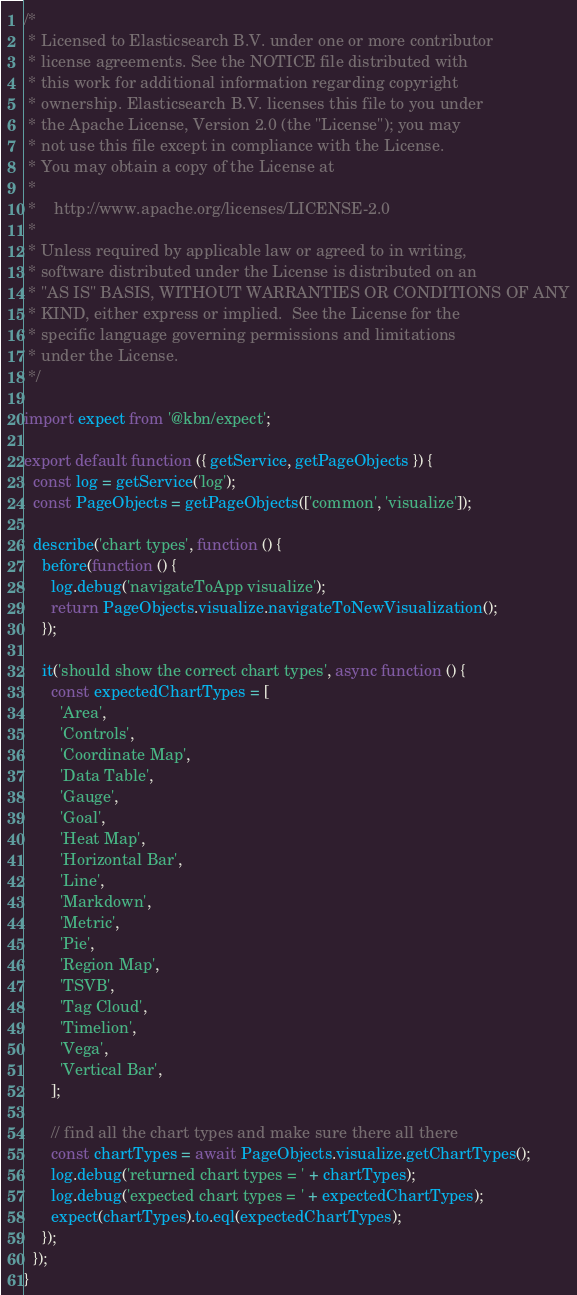Convert code to text. <code><loc_0><loc_0><loc_500><loc_500><_JavaScript_>/*
 * Licensed to Elasticsearch B.V. under one or more contributor
 * license agreements. See the NOTICE file distributed with
 * this work for additional information regarding copyright
 * ownership. Elasticsearch B.V. licenses this file to you under
 * the Apache License, Version 2.0 (the "License"); you may
 * not use this file except in compliance with the License.
 * You may obtain a copy of the License at
 *
 *    http://www.apache.org/licenses/LICENSE-2.0
 *
 * Unless required by applicable law or agreed to in writing,
 * software distributed under the License is distributed on an
 * "AS IS" BASIS, WITHOUT WARRANTIES OR CONDITIONS OF ANY
 * KIND, either express or implied.  See the License for the
 * specific language governing permissions and limitations
 * under the License.
 */

import expect from '@kbn/expect';

export default function ({ getService, getPageObjects }) {
  const log = getService('log');
  const PageObjects = getPageObjects(['common', 'visualize']);

  describe('chart types', function () {
    before(function () {
      log.debug('navigateToApp visualize');
      return PageObjects.visualize.navigateToNewVisualization();
    });

    it('should show the correct chart types', async function () {
      const expectedChartTypes = [
        'Area',
        'Controls',
        'Coordinate Map',
        'Data Table',
        'Gauge',
        'Goal',
        'Heat Map',
        'Horizontal Bar',
        'Line',
        'Markdown',
        'Metric',
        'Pie',
        'Region Map',
        'TSVB',
        'Tag Cloud',
        'Timelion',
        'Vega',
        'Vertical Bar',
      ];

      // find all the chart types and make sure there all there
      const chartTypes = await PageObjects.visualize.getChartTypes();
      log.debug('returned chart types = ' + chartTypes);
      log.debug('expected chart types = ' + expectedChartTypes);
      expect(chartTypes).to.eql(expectedChartTypes);
    });
  });
}
</code> 